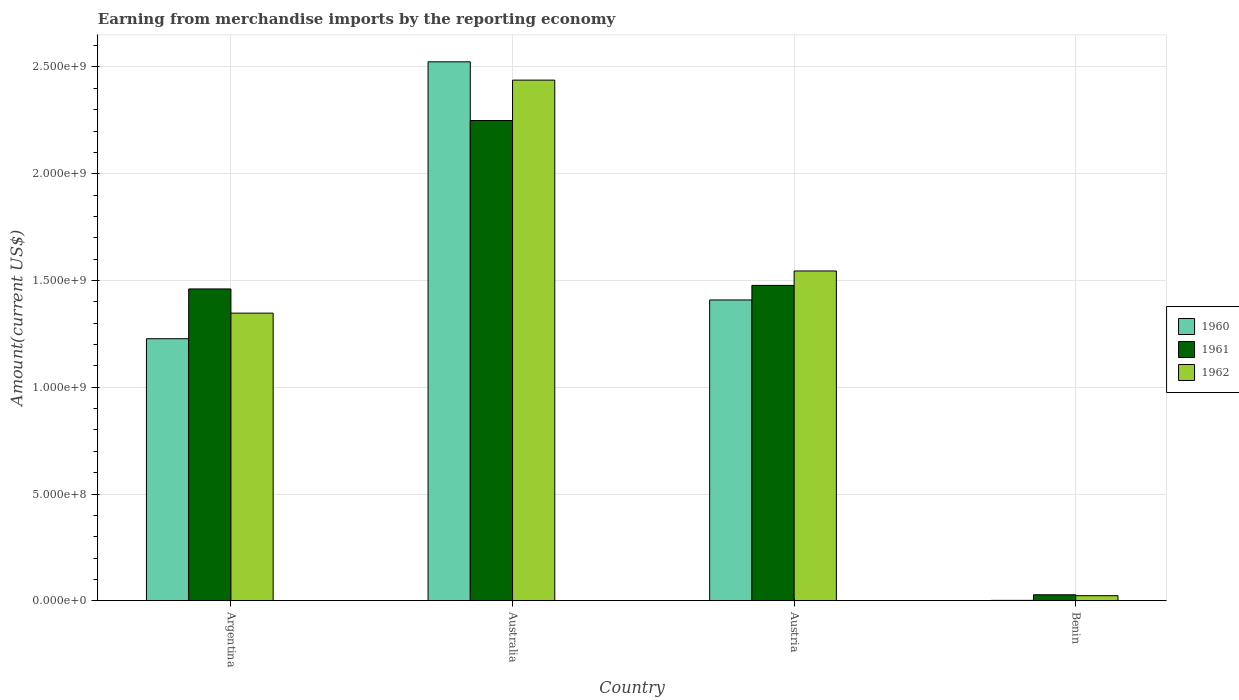How many different coloured bars are there?
Offer a very short reply. 3. How many groups of bars are there?
Your answer should be compact. 4. Are the number of bars on each tick of the X-axis equal?
Your answer should be very brief. Yes. How many bars are there on the 2nd tick from the left?
Provide a succinct answer. 3. How many bars are there on the 4th tick from the right?
Give a very brief answer. 3. What is the label of the 2nd group of bars from the left?
Ensure brevity in your answer.  Australia. What is the amount earned from merchandise imports in 1961 in Austria?
Offer a terse response. 1.48e+09. Across all countries, what is the maximum amount earned from merchandise imports in 1960?
Keep it short and to the point. 2.52e+09. Across all countries, what is the minimum amount earned from merchandise imports in 1962?
Provide a succinct answer. 2.38e+07. In which country was the amount earned from merchandise imports in 1961 maximum?
Provide a succinct answer. Australia. In which country was the amount earned from merchandise imports in 1961 minimum?
Your answer should be compact. Benin. What is the total amount earned from merchandise imports in 1962 in the graph?
Provide a short and direct response. 5.35e+09. What is the difference between the amount earned from merchandise imports in 1962 in Australia and that in Austria?
Your answer should be compact. 8.94e+08. What is the difference between the amount earned from merchandise imports in 1962 in Benin and the amount earned from merchandise imports in 1961 in Australia?
Make the answer very short. -2.23e+09. What is the average amount earned from merchandise imports in 1961 per country?
Your answer should be compact. 1.30e+09. What is the difference between the amount earned from merchandise imports of/in 1962 and amount earned from merchandise imports of/in 1960 in Benin?
Ensure brevity in your answer.  2.19e+07. In how many countries, is the amount earned from merchandise imports in 1960 greater than 1300000000 US$?
Your response must be concise. 2. What is the ratio of the amount earned from merchandise imports in 1962 in Austria to that in Benin?
Provide a short and direct response. 64.89. Is the amount earned from merchandise imports in 1961 in Argentina less than that in Australia?
Make the answer very short. Yes. What is the difference between the highest and the second highest amount earned from merchandise imports in 1961?
Your answer should be compact. 7.72e+08. What is the difference between the highest and the lowest amount earned from merchandise imports in 1962?
Your answer should be compact. 2.41e+09. What does the 2nd bar from the left in Argentina represents?
Offer a very short reply. 1961. What does the 3rd bar from the right in Argentina represents?
Your answer should be very brief. 1960. Is it the case that in every country, the sum of the amount earned from merchandise imports in 1962 and amount earned from merchandise imports in 1961 is greater than the amount earned from merchandise imports in 1960?
Ensure brevity in your answer.  Yes. What is the difference between two consecutive major ticks on the Y-axis?
Ensure brevity in your answer.  5.00e+08. Does the graph contain grids?
Keep it short and to the point. Yes. Where does the legend appear in the graph?
Provide a succinct answer. Center right. How many legend labels are there?
Your answer should be compact. 3. What is the title of the graph?
Your response must be concise. Earning from merchandise imports by the reporting economy. Does "2000" appear as one of the legend labels in the graph?
Provide a short and direct response. No. What is the label or title of the Y-axis?
Provide a succinct answer. Amount(current US$). What is the Amount(current US$) of 1960 in Argentina?
Keep it short and to the point. 1.23e+09. What is the Amount(current US$) of 1961 in Argentina?
Provide a short and direct response. 1.46e+09. What is the Amount(current US$) of 1962 in Argentina?
Make the answer very short. 1.35e+09. What is the Amount(current US$) in 1960 in Australia?
Give a very brief answer. 2.52e+09. What is the Amount(current US$) in 1961 in Australia?
Your answer should be compact. 2.25e+09. What is the Amount(current US$) in 1962 in Australia?
Keep it short and to the point. 2.44e+09. What is the Amount(current US$) of 1960 in Austria?
Offer a terse response. 1.41e+09. What is the Amount(current US$) in 1961 in Austria?
Make the answer very short. 1.48e+09. What is the Amount(current US$) in 1962 in Austria?
Your answer should be very brief. 1.54e+09. What is the Amount(current US$) in 1960 in Benin?
Your response must be concise. 1.90e+06. What is the Amount(current US$) in 1961 in Benin?
Ensure brevity in your answer.  2.81e+07. What is the Amount(current US$) in 1962 in Benin?
Offer a terse response. 2.38e+07. Across all countries, what is the maximum Amount(current US$) of 1960?
Offer a very short reply. 2.52e+09. Across all countries, what is the maximum Amount(current US$) of 1961?
Ensure brevity in your answer.  2.25e+09. Across all countries, what is the maximum Amount(current US$) of 1962?
Offer a very short reply. 2.44e+09. Across all countries, what is the minimum Amount(current US$) in 1960?
Provide a succinct answer. 1.90e+06. Across all countries, what is the minimum Amount(current US$) in 1961?
Your answer should be very brief. 2.81e+07. Across all countries, what is the minimum Amount(current US$) in 1962?
Offer a very short reply. 2.38e+07. What is the total Amount(current US$) of 1960 in the graph?
Make the answer very short. 5.16e+09. What is the total Amount(current US$) of 1961 in the graph?
Offer a terse response. 5.21e+09. What is the total Amount(current US$) in 1962 in the graph?
Offer a very short reply. 5.35e+09. What is the difference between the Amount(current US$) in 1960 in Argentina and that in Australia?
Make the answer very short. -1.30e+09. What is the difference between the Amount(current US$) of 1961 in Argentina and that in Australia?
Keep it short and to the point. -7.89e+08. What is the difference between the Amount(current US$) in 1962 in Argentina and that in Australia?
Offer a very short reply. -1.09e+09. What is the difference between the Amount(current US$) in 1960 in Argentina and that in Austria?
Make the answer very short. -1.82e+08. What is the difference between the Amount(current US$) in 1961 in Argentina and that in Austria?
Offer a very short reply. -1.66e+07. What is the difference between the Amount(current US$) in 1962 in Argentina and that in Austria?
Your response must be concise. -1.97e+08. What is the difference between the Amount(current US$) of 1960 in Argentina and that in Benin?
Provide a short and direct response. 1.23e+09. What is the difference between the Amount(current US$) in 1961 in Argentina and that in Benin?
Offer a very short reply. 1.43e+09. What is the difference between the Amount(current US$) of 1962 in Argentina and that in Benin?
Make the answer very short. 1.32e+09. What is the difference between the Amount(current US$) in 1960 in Australia and that in Austria?
Make the answer very short. 1.12e+09. What is the difference between the Amount(current US$) in 1961 in Australia and that in Austria?
Provide a short and direct response. 7.72e+08. What is the difference between the Amount(current US$) of 1962 in Australia and that in Austria?
Your answer should be very brief. 8.94e+08. What is the difference between the Amount(current US$) of 1960 in Australia and that in Benin?
Offer a terse response. 2.52e+09. What is the difference between the Amount(current US$) of 1961 in Australia and that in Benin?
Ensure brevity in your answer.  2.22e+09. What is the difference between the Amount(current US$) in 1962 in Australia and that in Benin?
Your answer should be compact. 2.41e+09. What is the difference between the Amount(current US$) in 1960 in Austria and that in Benin?
Make the answer very short. 1.41e+09. What is the difference between the Amount(current US$) in 1961 in Austria and that in Benin?
Ensure brevity in your answer.  1.45e+09. What is the difference between the Amount(current US$) of 1962 in Austria and that in Benin?
Ensure brevity in your answer.  1.52e+09. What is the difference between the Amount(current US$) in 1960 in Argentina and the Amount(current US$) in 1961 in Australia?
Provide a succinct answer. -1.02e+09. What is the difference between the Amount(current US$) of 1960 in Argentina and the Amount(current US$) of 1962 in Australia?
Your answer should be compact. -1.21e+09. What is the difference between the Amount(current US$) of 1961 in Argentina and the Amount(current US$) of 1962 in Australia?
Provide a succinct answer. -9.78e+08. What is the difference between the Amount(current US$) of 1960 in Argentina and the Amount(current US$) of 1961 in Austria?
Give a very brief answer. -2.50e+08. What is the difference between the Amount(current US$) in 1960 in Argentina and the Amount(current US$) in 1962 in Austria?
Keep it short and to the point. -3.17e+08. What is the difference between the Amount(current US$) in 1961 in Argentina and the Amount(current US$) in 1962 in Austria?
Give a very brief answer. -8.41e+07. What is the difference between the Amount(current US$) in 1960 in Argentina and the Amount(current US$) in 1961 in Benin?
Your response must be concise. 1.20e+09. What is the difference between the Amount(current US$) of 1960 in Argentina and the Amount(current US$) of 1962 in Benin?
Give a very brief answer. 1.20e+09. What is the difference between the Amount(current US$) of 1961 in Argentina and the Amount(current US$) of 1962 in Benin?
Ensure brevity in your answer.  1.44e+09. What is the difference between the Amount(current US$) in 1960 in Australia and the Amount(current US$) in 1961 in Austria?
Offer a terse response. 1.05e+09. What is the difference between the Amount(current US$) of 1960 in Australia and the Amount(current US$) of 1962 in Austria?
Your answer should be compact. 9.80e+08. What is the difference between the Amount(current US$) of 1961 in Australia and the Amount(current US$) of 1962 in Austria?
Your response must be concise. 7.05e+08. What is the difference between the Amount(current US$) in 1960 in Australia and the Amount(current US$) in 1961 in Benin?
Give a very brief answer. 2.50e+09. What is the difference between the Amount(current US$) in 1960 in Australia and the Amount(current US$) in 1962 in Benin?
Offer a very short reply. 2.50e+09. What is the difference between the Amount(current US$) of 1961 in Australia and the Amount(current US$) of 1962 in Benin?
Your answer should be very brief. 2.23e+09. What is the difference between the Amount(current US$) in 1960 in Austria and the Amount(current US$) in 1961 in Benin?
Keep it short and to the point. 1.38e+09. What is the difference between the Amount(current US$) of 1960 in Austria and the Amount(current US$) of 1962 in Benin?
Offer a very short reply. 1.38e+09. What is the difference between the Amount(current US$) of 1961 in Austria and the Amount(current US$) of 1962 in Benin?
Ensure brevity in your answer.  1.45e+09. What is the average Amount(current US$) of 1960 per country?
Your response must be concise. 1.29e+09. What is the average Amount(current US$) in 1961 per country?
Make the answer very short. 1.30e+09. What is the average Amount(current US$) of 1962 per country?
Ensure brevity in your answer.  1.34e+09. What is the difference between the Amount(current US$) in 1960 and Amount(current US$) in 1961 in Argentina?
Your response must be concise. -2.33e+08. What is the difference between the Amount(current US$) of 1960 and Amount(current US$) of 1962 in Argentina?
Ensure brevity in your answer.  -1.20e+08. What is the difference between the Amount(current US$) in 1961 and Amount(current US$) in 1962 in Argentina?
Ensure brevity in your answer.  1.13e+08. What is the difference between the Amount(current US$) in 1960 and Amount(current US$) in 1961 in Australia?
Your answer should be compact. 2.75e+08. What is the difference between the Amount(current US$) in 1960 and Amount(current US$) in 1962 in Australia?
Your answer should be compact. 8.57e+07. What is the difference between the Amount(current US$) of 1961 and Amount(current US$) of 1962 in Australia?
Your answer should be very brief. -1.89e+08. What is the difference between the Amount(current US$) in 1960 and Amount(current US$) in 1961 in Austria?
Offer a very short reply. -6.82e+07. What is the difference between the Amount(current US$) of 1960 and Amount(current US$) of 1962 in Austria?
Your answer should be compact. -1.36e+08. What is the difference between the Amount(current US$) of 1961 and Amount(current US$) of 1962 in Austria?
Provide a short and direct response. -6.75e+07. What is the difference between the Amount(current US$) in 1960 and Amount(current US$) in 1961 in Benin?
Make the answer very short. -2.62e+07. What is the difference between the Amount(current US$) of 1960 and Amount(current US$) of 1962 in Benin?
Offer a very short reply. -2.19e+07. What is the difference between the Amount(current US$) of 1961 and Amount(current US$) of 1962 in Benin?
Provide a succinct answer. 4.30e+06. What is the ratio of the Amount(current US$) of 1960 in Argentina to that in Australia?
Give a very brief answer. 0.49. What is the ratio of the Amount(current US$) of 1961 in Argentina to that in Australia?
Keep it short and to the point. 0.65. What is the ratio of the Amount(current US$) in 1962 in Argentina to that in Australia?
Make the answer very short. 0.55. What is the ratio of the Amount(current US$) in 1960 in Argentina to that in Austria?
Offer a terse response. 0.87. What is the ratio of the Amount(current US$) in 1961 in Argentina to that in Austria?
Give a very brief answer. 0.99. What is the ratio of the Amount(current US$) in 1962 in Argentina to that in Austria?
Provide a short and direct response. 0.87. What is the ratio of the Amount(current US$) in 1960 in Argentina to that in Benin?
Offer a terse response. 645.95. What is the ratio of the Amount(current US$) in 1961 in Argentina to that in Benin?
Keep it short and to the point. 51.97. What is the ratio of the Amount(current US$) of 1962 in Argentina to that in Benin?
Your answer should be compact. 56.6. What is the ratio of the Amount(current US$) in 1960 in Australia to that in Austria?
Offer a terse response. 1.79. What is the ratio of the Amount(current US$) of 1961 in Australia to that in Austria?
Provide a short and direct response. 1.52. What is the ratio of the Amount(current US$) of 1962 in Australia to that in Austria?
Give a very brief answer. 1.58. What is the ratio of the Amount(current US$) in 1960 in Australia to that in Benin?
Your answer should be very brief. 1328.45. What is the ratio of the Amount(current US$) in 1961 in Australia to that in Benin?
Your response must be concise. 80.04. What is the ratio of the Amount(current US$) of 1962 in Australia to that in Benin?
Keep it short and to the point. 102.45. What is the ratio of the Amount(current US$) in 1960 in Austria to that in Benin?
Offer a very short reply. 741.47. What is the ratio of the Amount(current US$) in 1961 in Austria to that in Benin?
Your response must be concise. 52.56. What is the ratio of the Amount(current US$) in 1962 in Austria to that in Benin?
Ensure brevity in your answer.  64.89. What is the difference between the highest and the second highest Amount(current US$) in 1960?
Provide a short and direct response. 1.12e+09. What is the difference between the highest and the second highest Amount(current US$) of 1961?
Provide a succinct answer. 7.72e+08. What is the difference between the highest and the second highest Amount(current US$) of 1962?
Give a very brief answer. 8.94e+08. What is the difference between the highest and the lowest Amount(current US$) in 1960?
Your answer should be compact. 2.52e+09. What is the difference between the highest and the lowest Amount(current US$) of 1961?
Your answer should be compact. 2.22e+09. What is the difference between the highest and the lowest Amount(current US$) in 1962?
Your answer should be compact. 2.41e+09. 